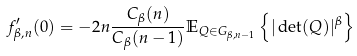<formula> <loc_0><loc_0><loc_500><loc_500>f _ { \beta , n } ^ { \prime } ( 0 ) = - 2 n \frac { C _ { \beta } ( n ) } { C _ { \beta } ( n - 1 ) } \mathbb { E } _ { Q \in G _ { \beta , n - 1 } } \left \{ | \det ( Q ) | ^ { \beta } \right \}</formula> 